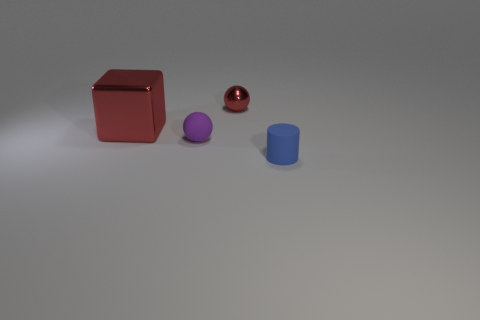Add 3 large brown matte blocks. How many objects exist? 7 Subtract all cylinders. How many objects are left? 3 Subtract 0 cyan spheres. How many objects are left? 4 Subtract all metallic blocks. Subtract all big red metallic things. How many objects are left? 2 Add 1 small blue rubber things. How many small blue rubber things are left? 2 Add 1 tiny purple things. How many tiny purple things exist? 2 